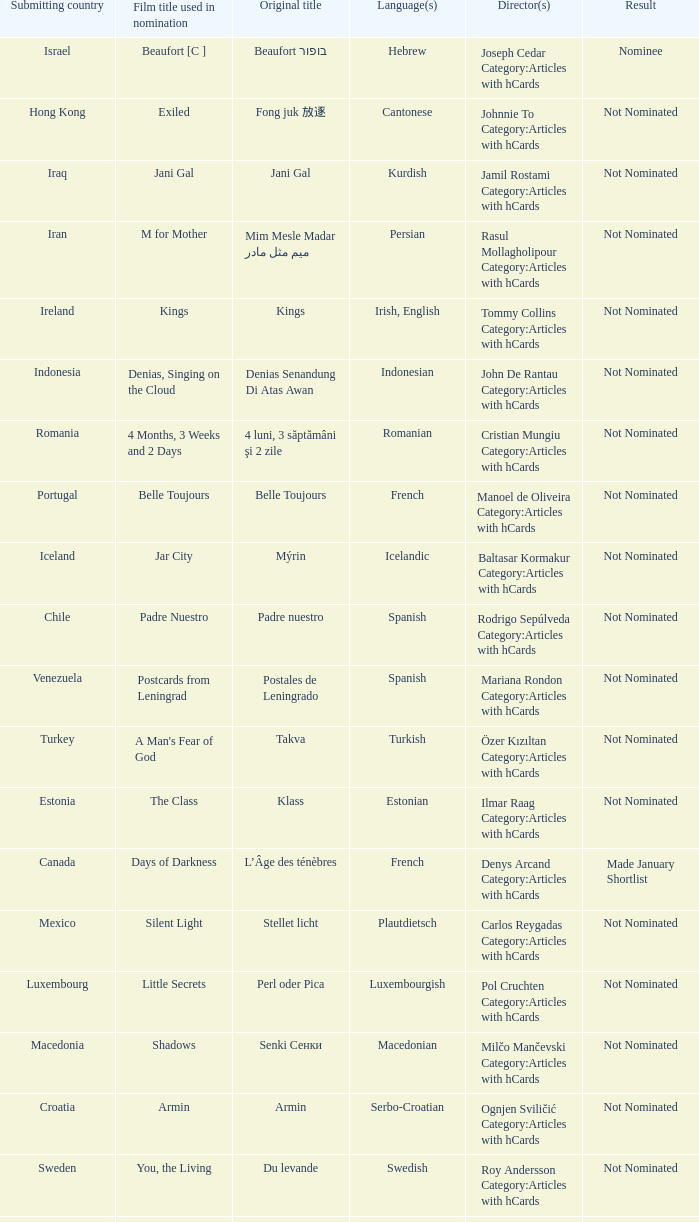What country submitted miehen työ? Finland. 